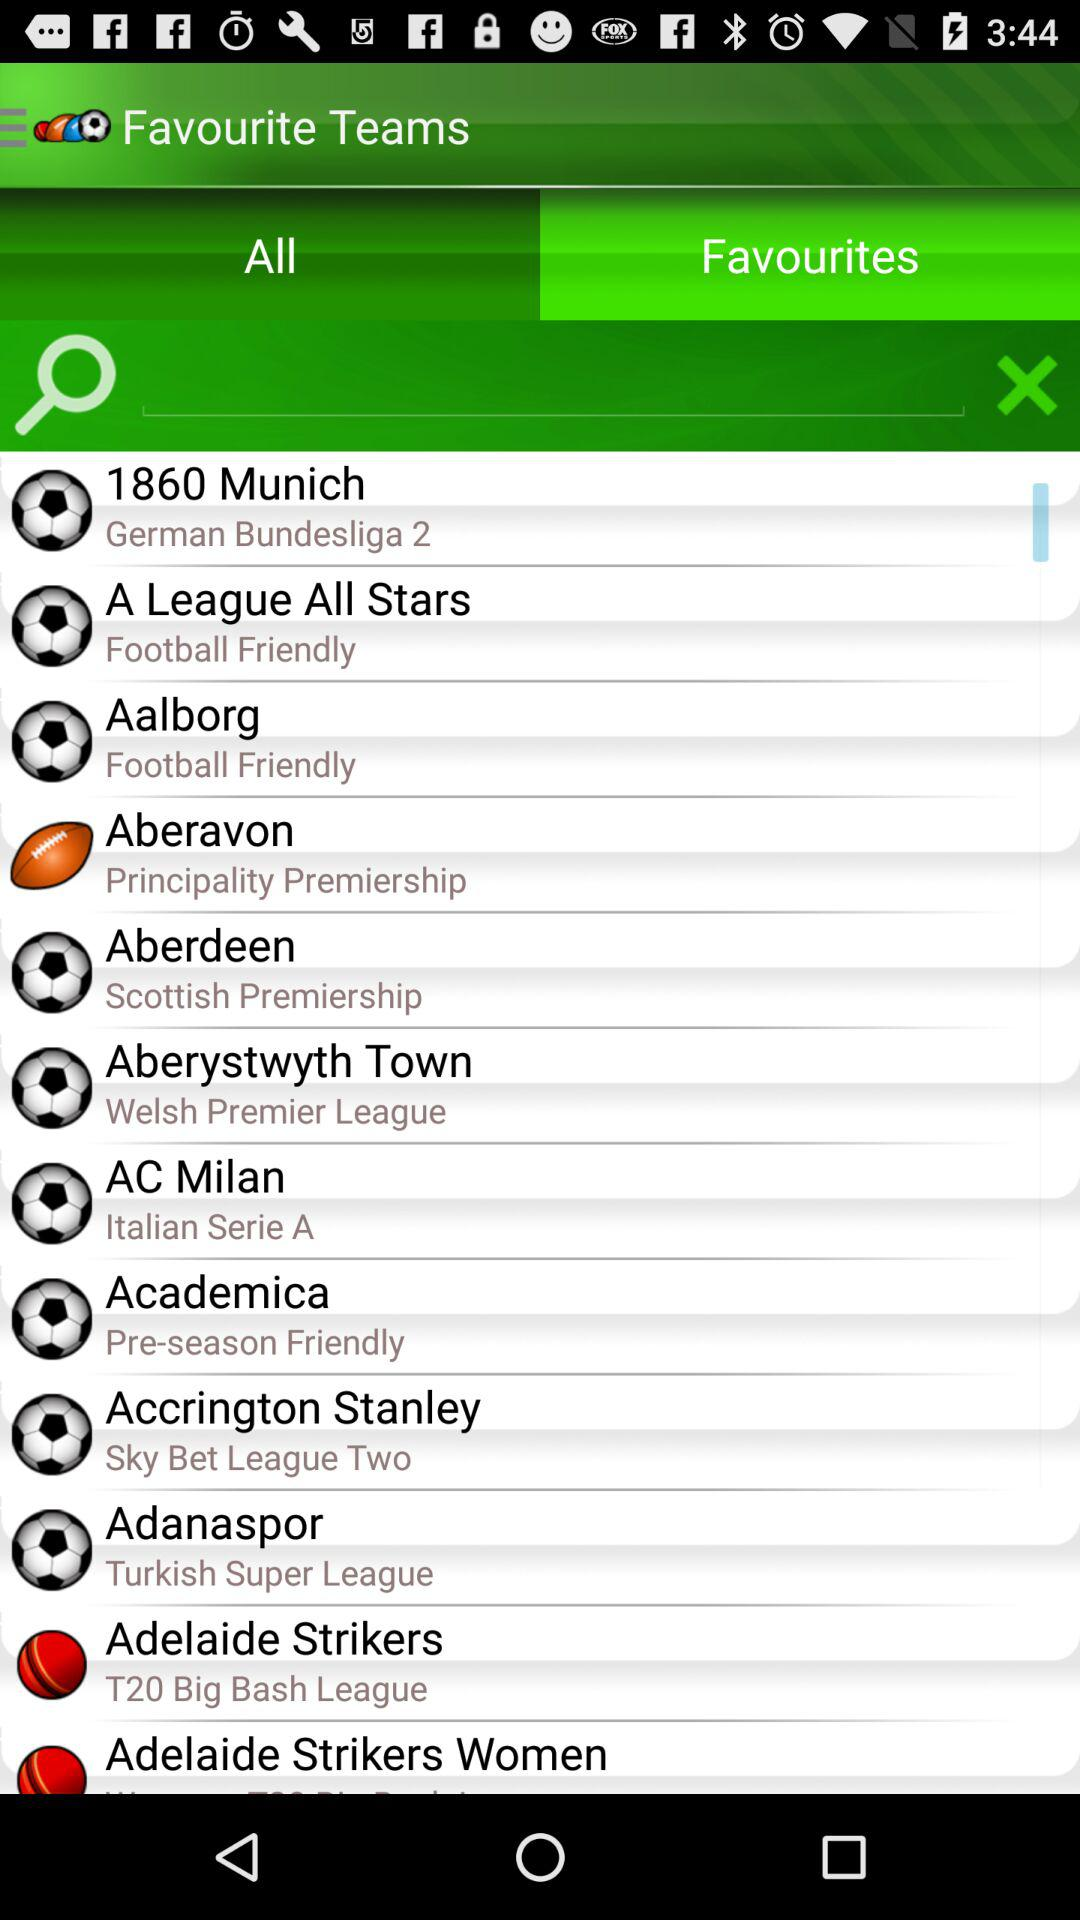In which league do "Adelaide Strikers" play? "Adelaide Strikers" play in the T20 Big Bash League. 